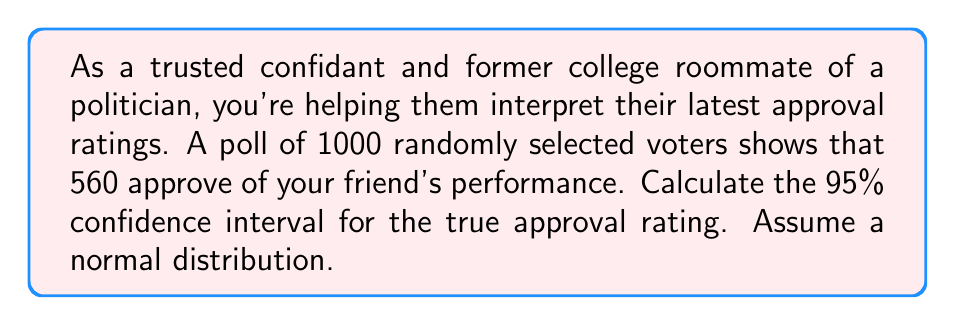What is the answer to this math problem? To calculate the confidence interval, we'll follow these steps:

1) First, calculate the point estimate (p̂):
   $\hat{p} = \frac{\text{number of successes}}{\text{sample size}} = \frac{560}{1000} = 0.56$ or 56%

2) Calculate the standard error (SE):
   $SE = \sqrt{\frac{\hat{p}(1-\hat{p})}{n}}$
   Where n is the sample size.
   
   $SE = \sqrt{\frac{0.56(1-0.56)}{1000}} = \sqrt{\frac{0.2464}{1000}} = 0.0157$

3) For a 95% confidence interval, we use a z-score of 1.96 (from the standard normal distribution).

4) The formula for the confidence interval is:
   $\hat{p} \pm (z \times SE)$

5) Plugging in our values:
   $0.56 \pm (1.96 \times 0.0157)$
   $0.56 \pm 0.0308$

6) Therefore, the confidence interval is:
   $(0.56 - 0.0308, 0.56 + 0.0308)$
   $(0.5292, 0.5908)$

This means we can be 95% confident that the true approval rating falls between 52.92% and 59.08%.
Answer: The 95% confidence interval for the true approval rating is (52.92%, 59.08%). 